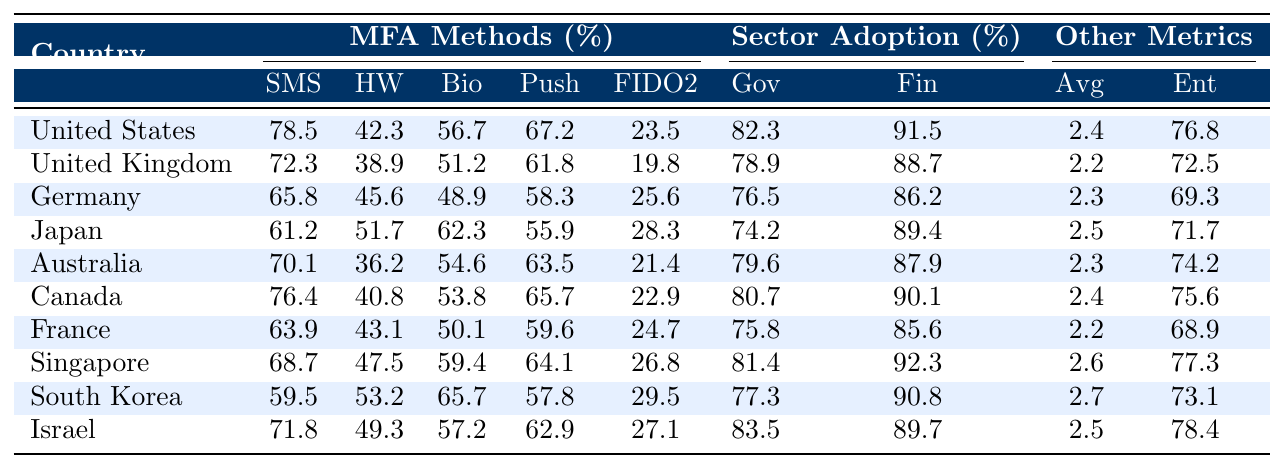What is the adoption rate of SMS OTP in the United States? The table shows the SMS OTP adoption rate specifically for the United States is 78.5%.
Answer: 78.5% Which country has the highest percentage of enterprises using MFA? Referring to the table, Israel has the highest percentage of enterprises using MFA, at 78.4%.
Answer: Israel What is the average adoption rate of hardware tokens across all countries listed? To find the average, we add the adoption rates of hardware tokens (42.3 + 38.9 + 45.6 + 51.7 + 36.2 + 40.8 + 43.1 + 47.5 + 53.2 + 49.3 = 449.6) and divide by the number of countries (10), which gives us 44.96.
Answer: 44.96 Is Japan’s FIDO2 Security Key adoption rate higher or lower than the average for all countries? Japan's FIDO2 adoption rate is 28.3%, while the average for all countries is (23.5 + 19.8 + 25.6 + 28.3 + 21.4 + 22.9 + 24.7 + 26.8 + 29.5 + 27.1) / 10 = 25.5%. Since 28.3 is greater than 25.5, it is higher.
Answer: Higher Which country has the lowest adoption of biometrics and what is the percentage? Reviewing the table, Germany has the lowest adoption of biometric methods at 48.9%.
Answer: Germany, 48.9% What is the difference in government sector adoption rates between the United States and the United Kingdom? The government sector adoption rate in the United States is 82.3% and in the United Kingdom, it is 78.9%. The difference is 82.3 - 78.9 = 3.4%.
Answer: 3.4% What percentage of enterprises in South Korea uses MFA? The table indicates that in South Korea, 73.1% of enterprises use MFA.
Answer: 73.1% Which country reported the highest average number of MFA methods per user and what is the number? The highest average number of MFA methods per user is in South Korea, which has 2.7 methods per user.
Answer: South Korea, 2.7 Are more users in Canada or Australia adopting hardware tokens? The hardware token adoption rate in Canada is 40.8% and in Australia, it is 36.2%. Since 40.8% is greater, more users in Canada adopt hardware tokens than in Australia.
Answer: Canada What is the trend in SMS OTP adoption from Germany to Singapore? The SMS OTP adoption rates increase from Germany (65.8%) to Singapore (68.7%), indicating a positive trend in this case.
Answer: Positive trend 